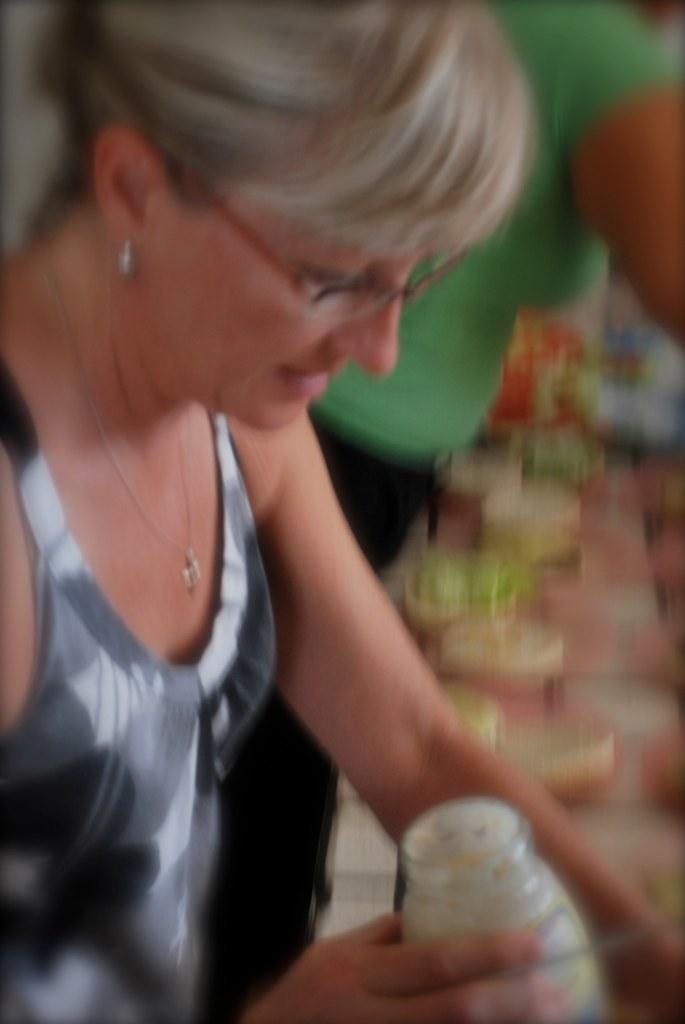Who is the main subject in the image? There is a woman in the image. Where is the woman located in the image? The woman is on the left side of the image. What is the woman wearing in the image? The woman is wearing a dress and spectacles. What is the woman holding in the image? The woman is holding a glass jar in her hand. What direction is the stranger pointing in the image? There is no stranger present in the image, and therefore no one is pointing in any direction. 